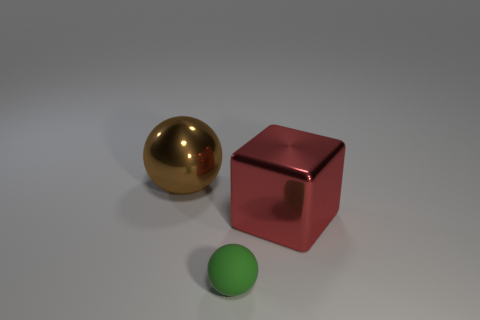Add 2 tiny blue metal cylinders. How many objects exist? 5 Subtract all blocks. How many objects are left? 2 Subtract 1 green balls. How many objects are left? 2 Subtract all large brown things. Subtract all balls. How many objects are left? 0 Add 1 tiny green matte spheres. How many tiny green matte spheres are left? 2 Add 3 blue things. How many blue things exist? 3 